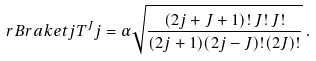<formula> <loc_0><loc_0><loc_500><loc_500>\ r B r a k e t { j } { T ^ { J } } { j } = \alpha \sqrt { \frac { ( 2 j + J + 1 ) ! \, J ! \, J ! } { ( 2 j + 1 ) ( 2 j - J ) ! ( 2 J ) ! } } \, .</formula> 